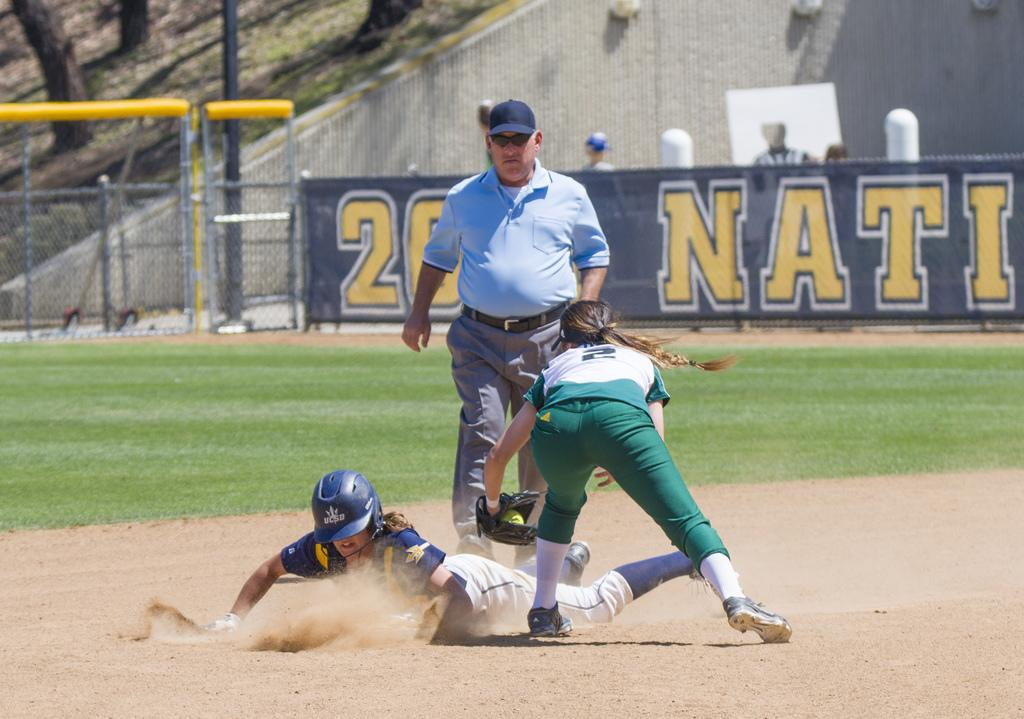<image>
Give a short and clear explanation of the subsequent image. Number 2 has the ball in her glove and trying to tag out the base runner who is sliding into the base. 